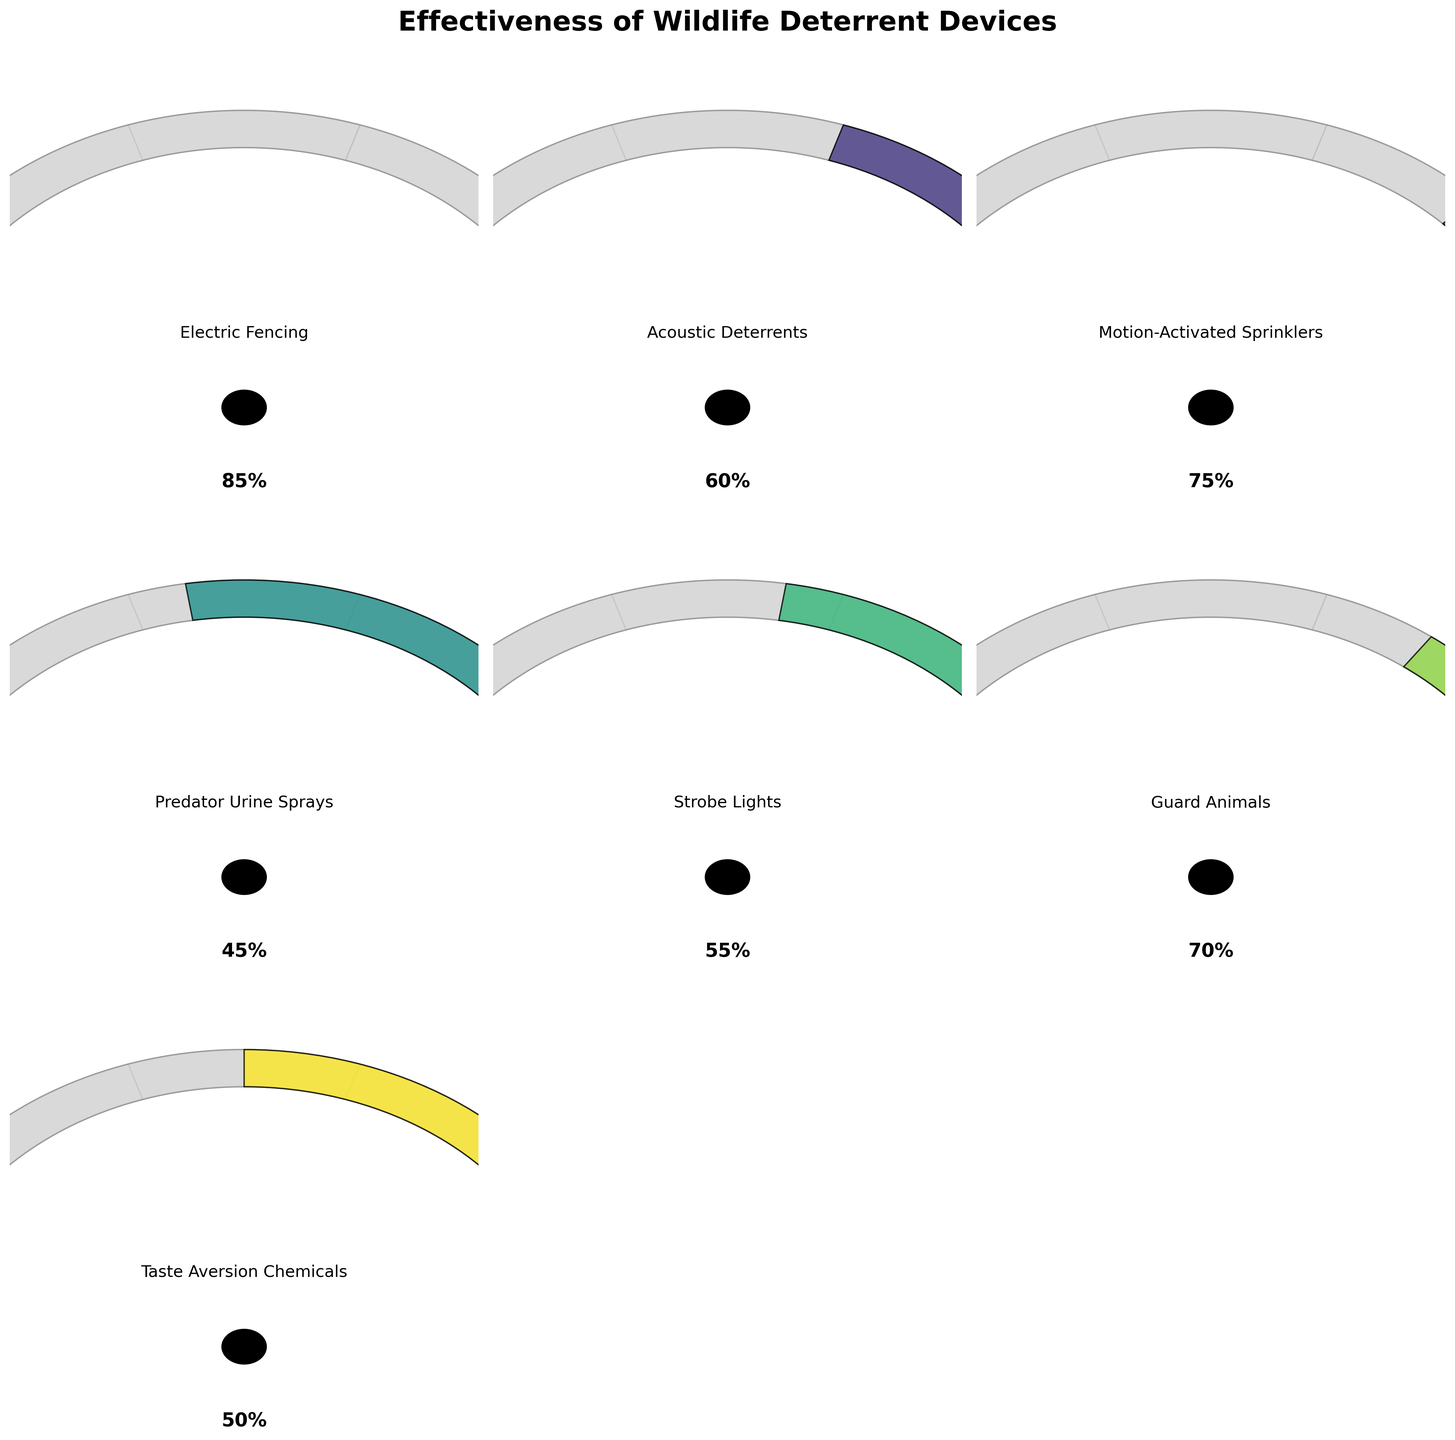What is the effectiveness percentage of Electric Fencing? The gauge chart for Electric Fencing shows an effectiveness percentage on the scale provided.
Answer: 85% Which device has the lowest effectiveness? By comparing all the effectiveness percentages on the gauge charts, Predator Urine Sprays has the lowest effectiveness.
Answer: Predator Urine Sprays How many devices have an effectiveness of 60% or higher? From the visual information, Electric Fencing (85%), Motion-Activated Sprinklers (75%), Guard Animals (70%), and Acoustic Deterrents (60%) are the devices with effectiveness 60% or higher.
Answer: 4 What is the average effectiveness of Acoustic Deterrents, Strobe Lights, and Taste Aversion Chemicals? The effectiveness percentages are 60%, 55%, and 50% respectively. Calculate the average as (60 + 55 + 50) / 3 = 55%.
Answer: 55% Which is more effective, Motion-Activated Sprinklers or Guard Animals? Check the gauge charts for each device. Motion-Activated Sprinklers has an effectiveness of 75% while Guard Animals has 70%.
Answer: Motion-Activated Sprinklers What is the range of effectiveness values for all devices? Identify the highest and lowest effectiveness values. The highest is 85% (Electric Fencing) and the lowest is 45% (Predator Urine Sprays). The range is 85% - 45% = 40%.
Answer: 40% How many devices have an effectiveness below 50%? From the visual information, only Predator Urine Sprays and Taste Aversion Chemicals are below 50%.
Answer: 2 Which device's effectiveness is closest to the median effectiveness of all devices? The effectiveness values are: 85, 60, 75, 45, 55, 70, 50. Sort these values: 45, 50, 55, 60, 70, 75, 85. The median is 60% (middle value). Acoustic Deterrents has an effectiveness of 60%.
Answer: Acoustic Deterrents 